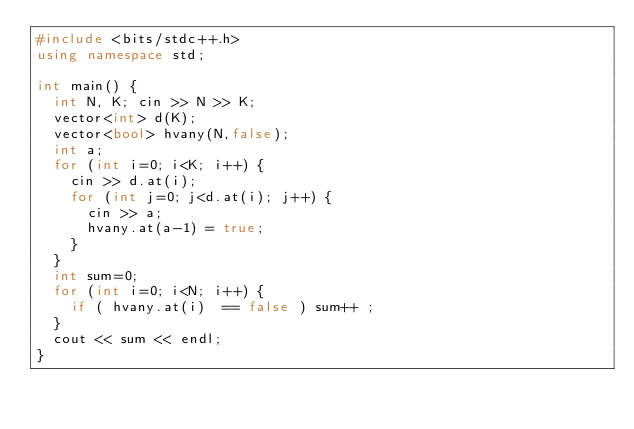Convert code to text. <code><loc_0><loc_0><loc_500><loc_500><_C++_>#include <bits/stdc++.h>
using namespace std;

int main() {
  int N, K; cin >> N >> K;
  vector<int> d(K);
  vector<bool> hvany(N,false);
  int a;
  for (int i=0; i<K; i++) {
    cin >> d.at(i);
    for (int j=0; j<d.at(i); j++) {
      cin >> a;
      hvany.at(a-1) = true;
    }
  }
  int sum=0;
  for (int i=0; i<N; i++) {
    if ( hvany.at(i)  == false ) sum++ ;
  }
  cout << sum << endl;
}
</code> 